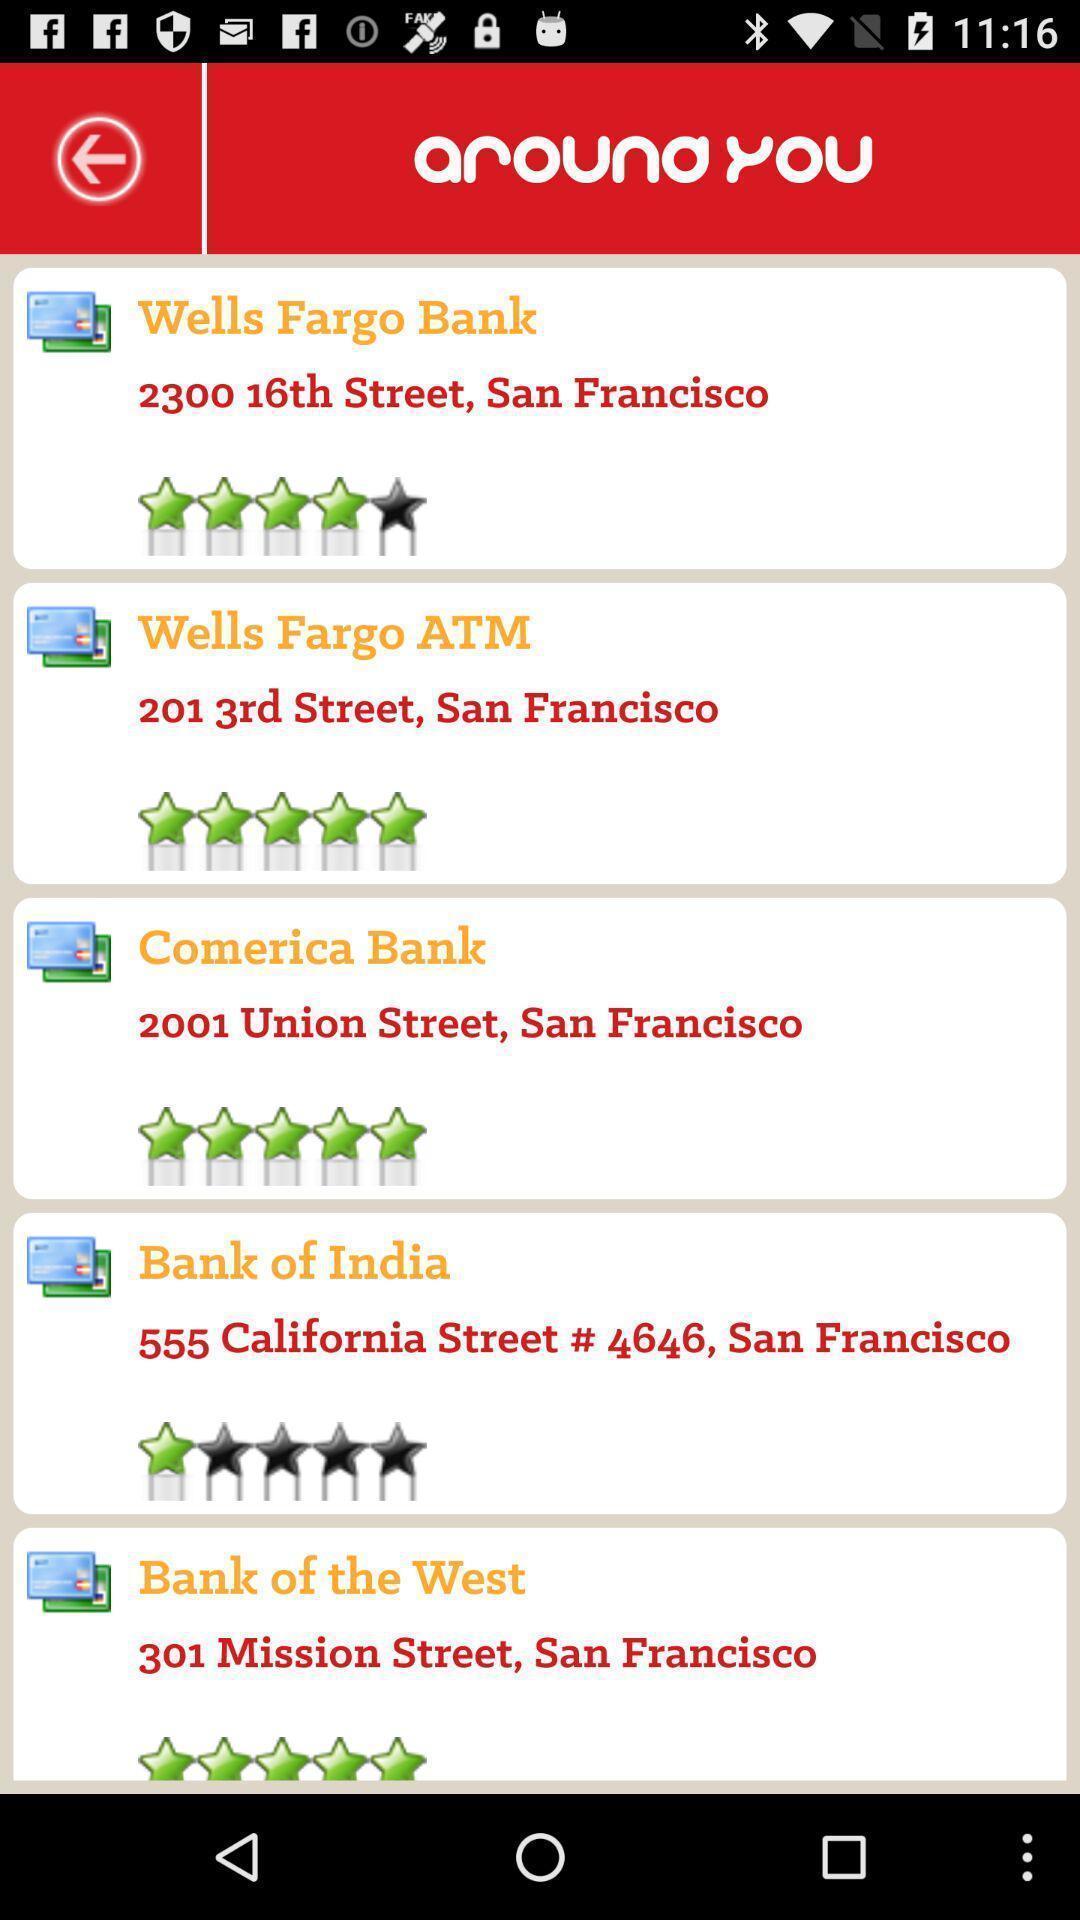Tell me about the visual elements in this screen capture. Screen showing bank names with ratings. 